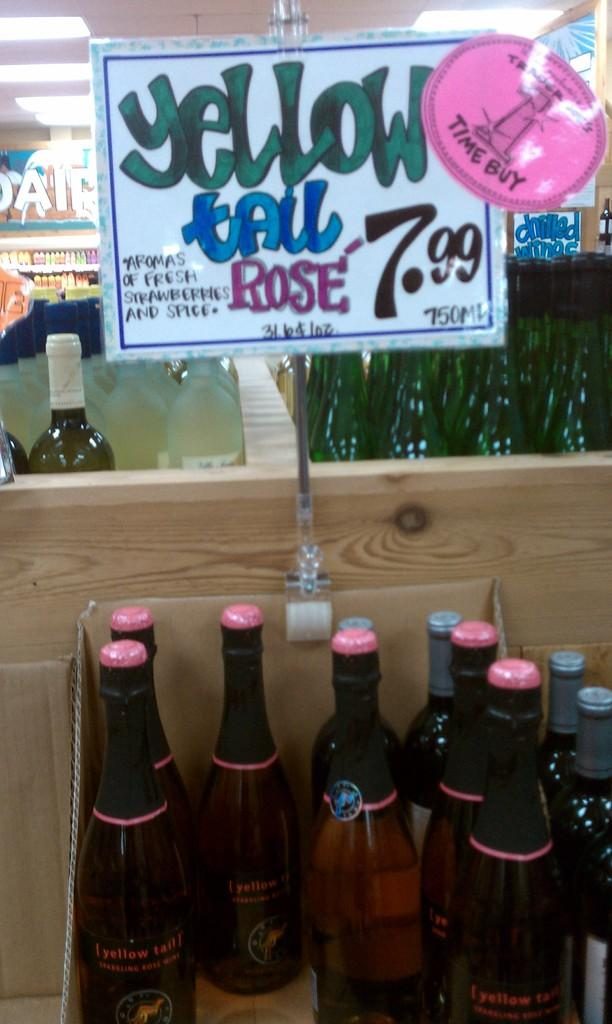<image>
Summarize the visual content of the image. A sign positioned above a wine bottle display that read "Yellow Tail Rose 7.99". 